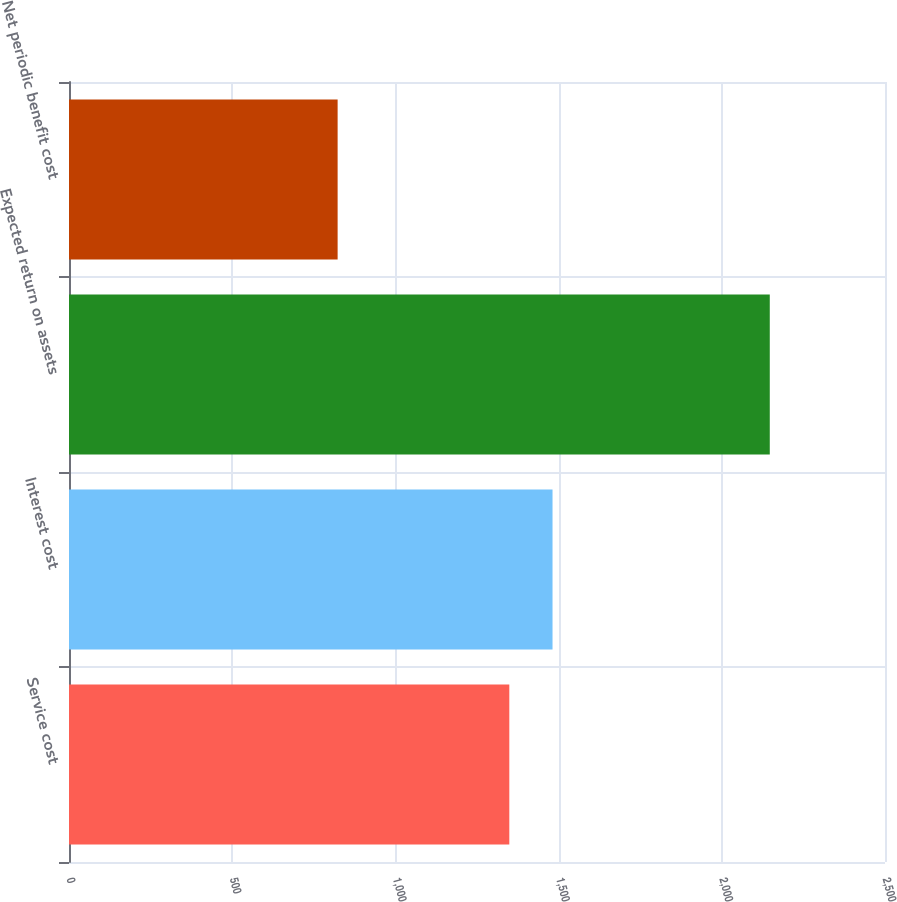<chart> <loc_0><loc_0><loc_500><loc_500><bar_chart><fcel>Service cost<fcel>Interest cost<fcel>Expected return on assets<fcel>Net periodic benefit cost<nl><fcel>1349<fcel>1481.4<fcel>2147<fcel>823<nl></chart> 